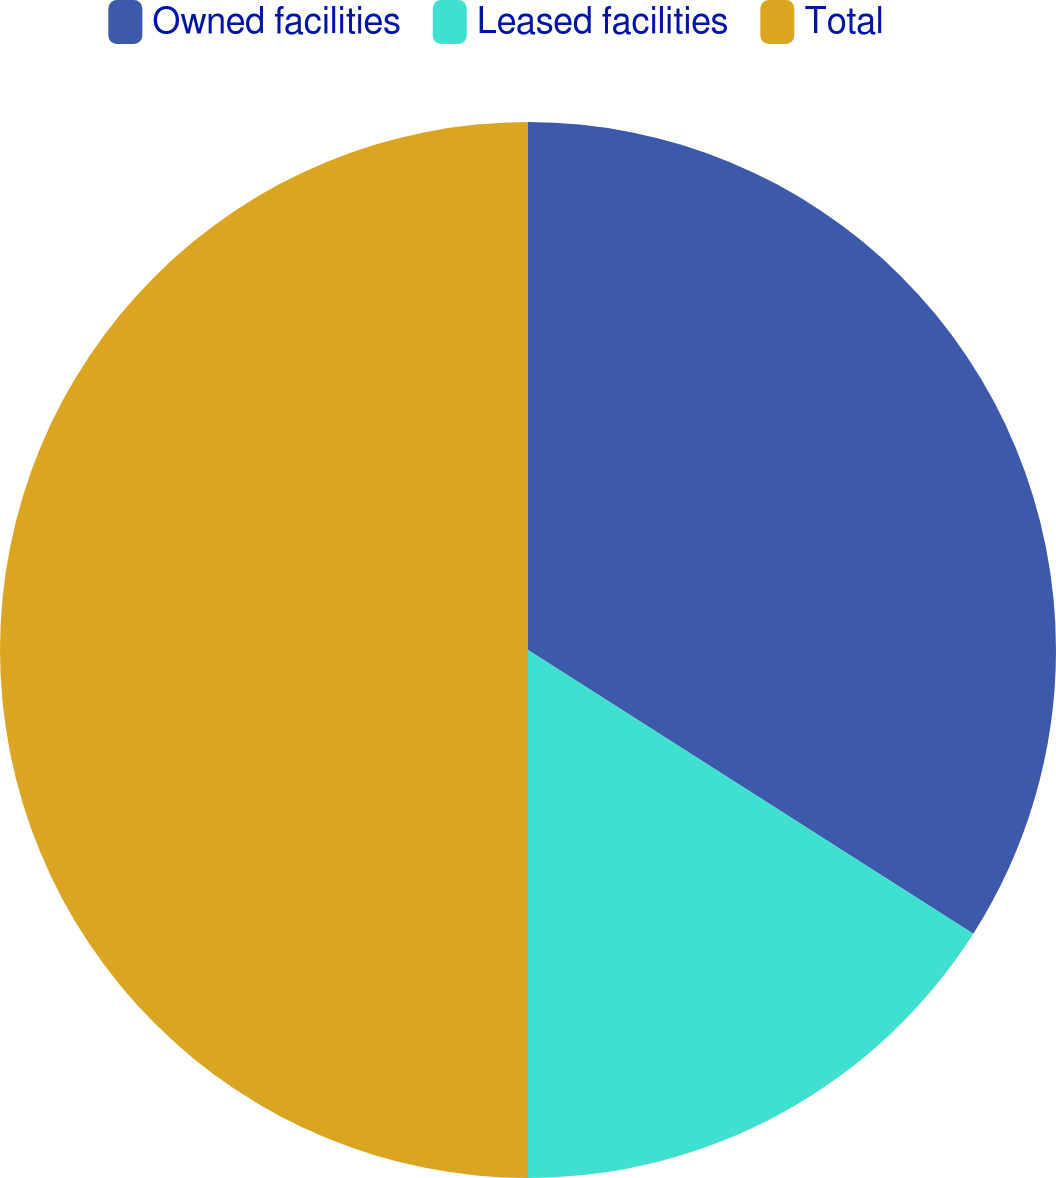<chart> <loc_0><loc_0><loc_500><loc_500><pie_chart><fcel>Owned facilities<fcel>Leased facilities<fcel>Total<nl><fcel>34.03%<fcel>15.97%<fcel>50.0%<nl></chart> 